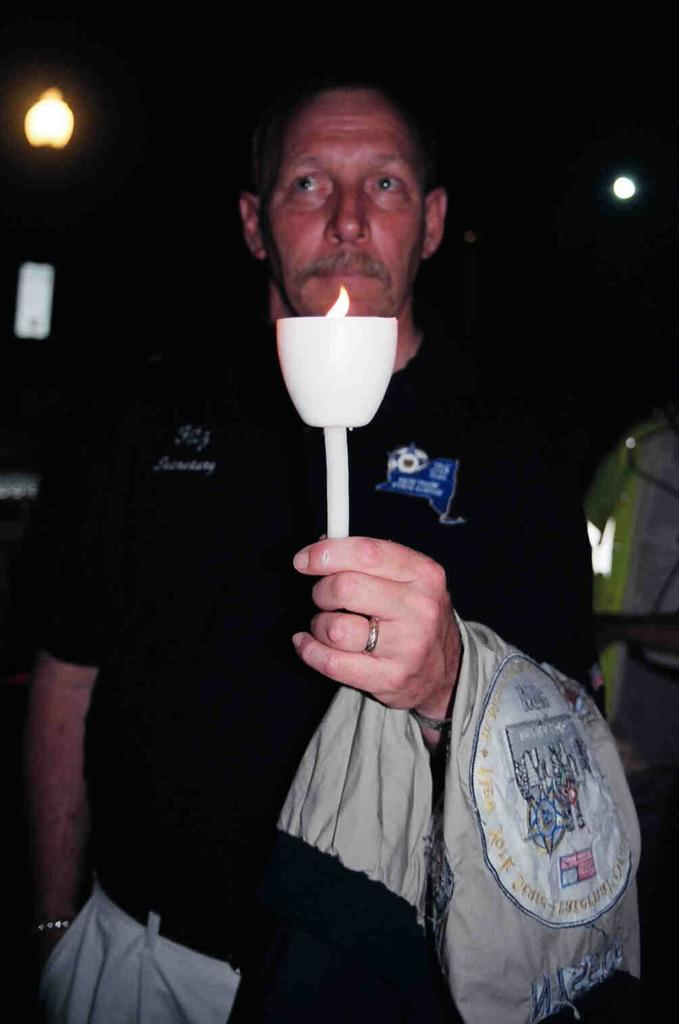What is the main subject in the foreground of the image? There is a person in the foreground of the image. What is the person doing in the image? The person is standing and holding a candle in their hand. What can be seen in the background of the image? There is a wall and lights in the background of the image. Where is the image taken? The image is taken in a room. What type of clover can be seen growing on the wall in the image? There is no clover present in the image; the background features a wall and lights, but no plants or vegetation. 